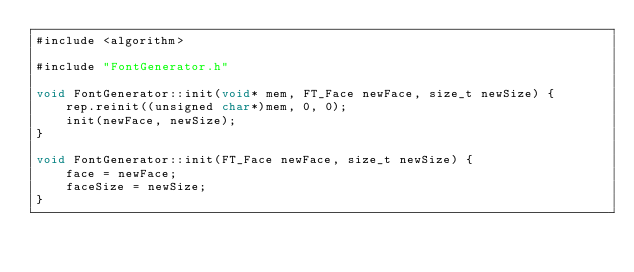Convert code to text. <code><loc_0><loc_0><loc_500><loc_500><_ObjectiveC_>#include <algorithm>

#include "FontGenerator.h"

void FontGenerator::init(void* mem, FT_Face newFace, size_t newSize) {
    rep.reinit((unsigned char*)mem, 0, 0);
    init(newFace, newSize);
}

void FontGenerator::init(FT_Face newFace, size_t newSize) {
    face = newFace;
    faceSize = newSize;
}
</code> 